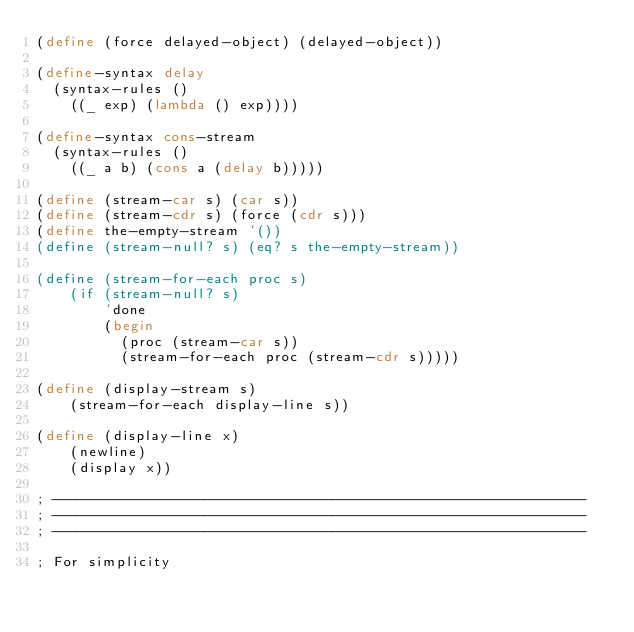<code> <loc_0><loc_0><loc_500><loc_500><_Scheme_>(define (force delayed-object) (delayed-object))

(define-syntax delay
  (syntax-rules ()
    ((_ exp) (lambda () exp))))

(define-syntax cons-stream
  (syntax-rules ()
    ((_ a b) (cons a (delay b)))))

(define (stream-car s) (car s))
(define (stream-cdr s) (force (cdr s)))
(define the-empty-stream '())
(define (stream-null? s) (eq? s the-empty-stream))

(define (stream-for-each proc s)
    (if (stream-null? s)
        'done
        (begin
          (proc (stream-car s))
          (stream-for-each proc (stream-cdr s)))))

(define (display-stream s)
    (stream-for-each display-line s))

(define (display-line x)
    (newline)
    (display x))

; ---------------------------------------------------------------
; ---------------------------------------------------------------
; ---------------------------------------------------------------

; For simplicity</code> 